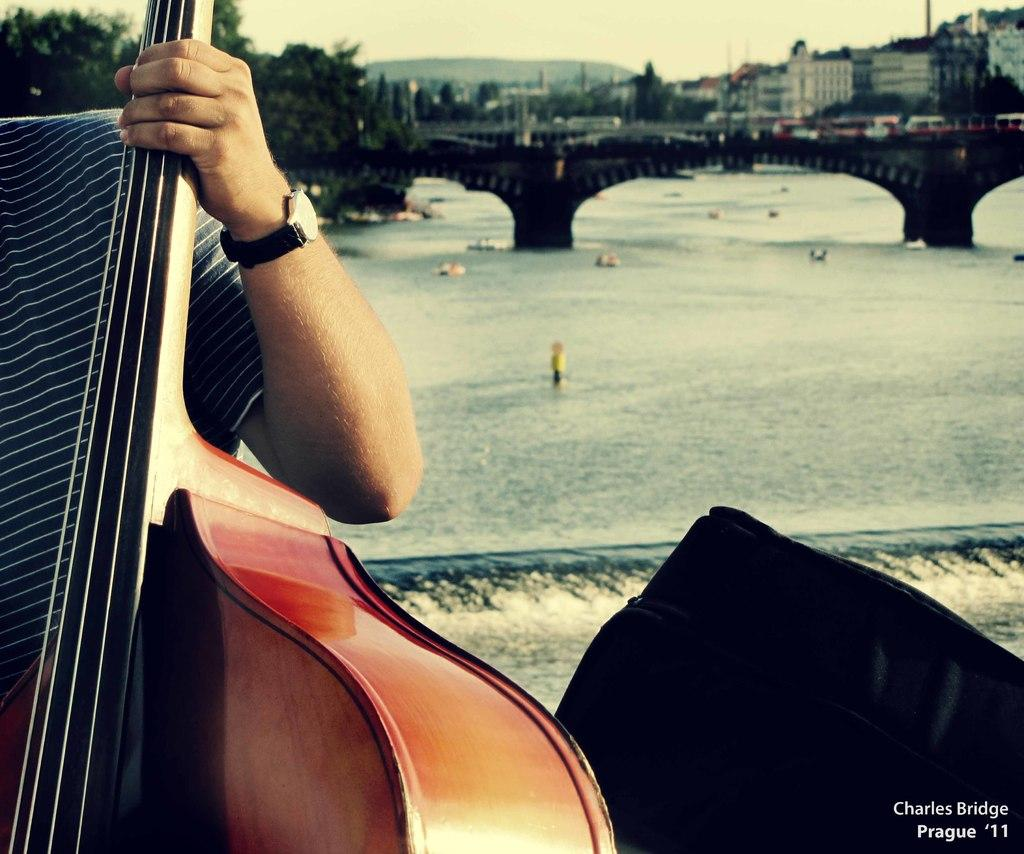What is the person in the image holding? The person is holding a guitar. What can be seen in the background of the image? There is water, a bridge, and buildings visible in the image. Can you describe the setting of the image? The image appears to be set near a body of water with a bridge and buildings in the background. How many cent bikes are parked near the person in the image? There are no bikes, let alone cent bikes, present in the image. 